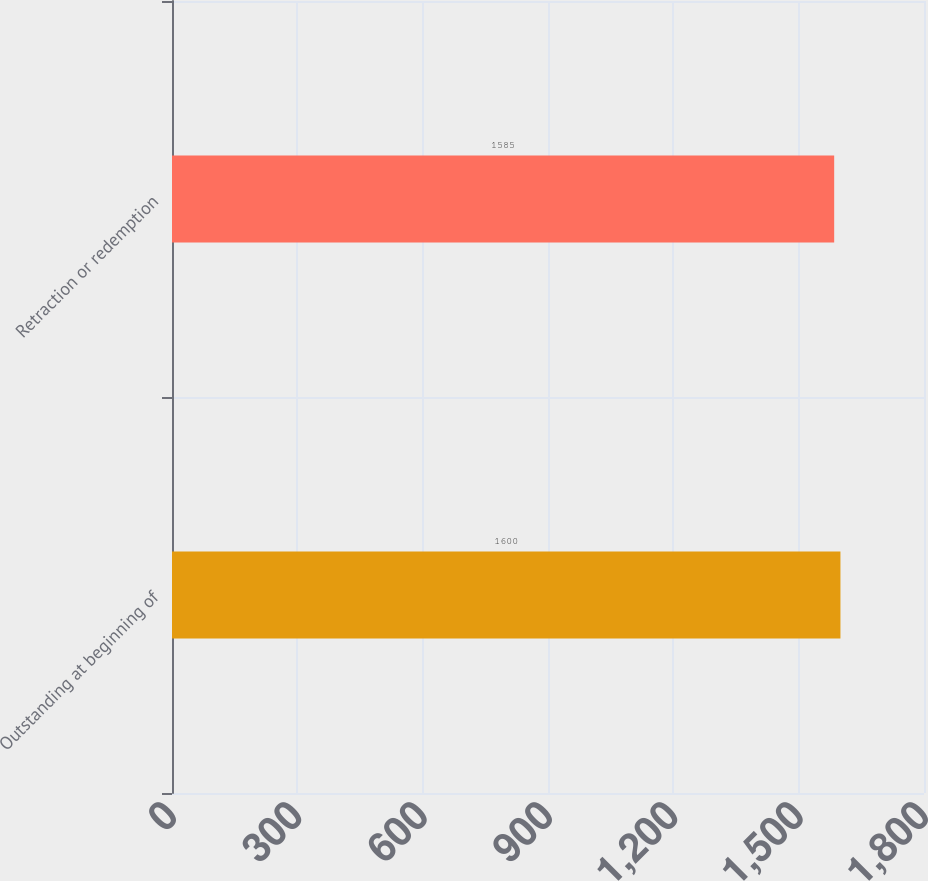Convert chart to OTSL. <chart><loc_0><loc_0><loc_500><loc_500><bar_chart><fcel>Outstanding at beginning of<fcel>Retraction or redemption<nl><fcel>1600<fcel>1585<nl></chart> 